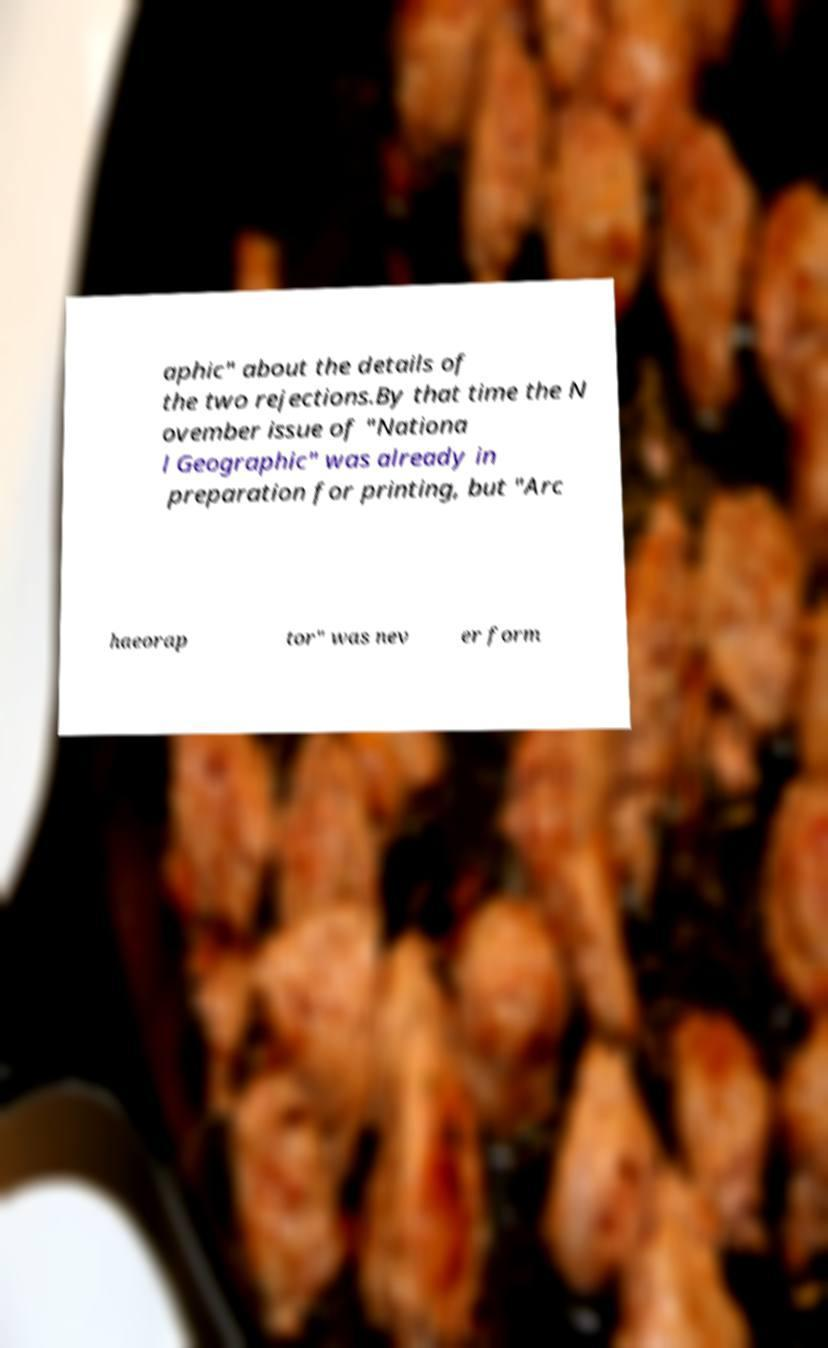Can you read and provide the text displayed in the image?This photo seems to have some interesting text. Can you extract and type it out for me? aphic" about the details of the two rejections.By that time the N ovember issue of "Nationa l Geographic" was already in preparation for printing, but "Arc haeorap tor" was nev er form 